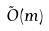<formula> <loc_0><loc_0><loc_500><loc_500>\tilde { O } ( m )</formula> 